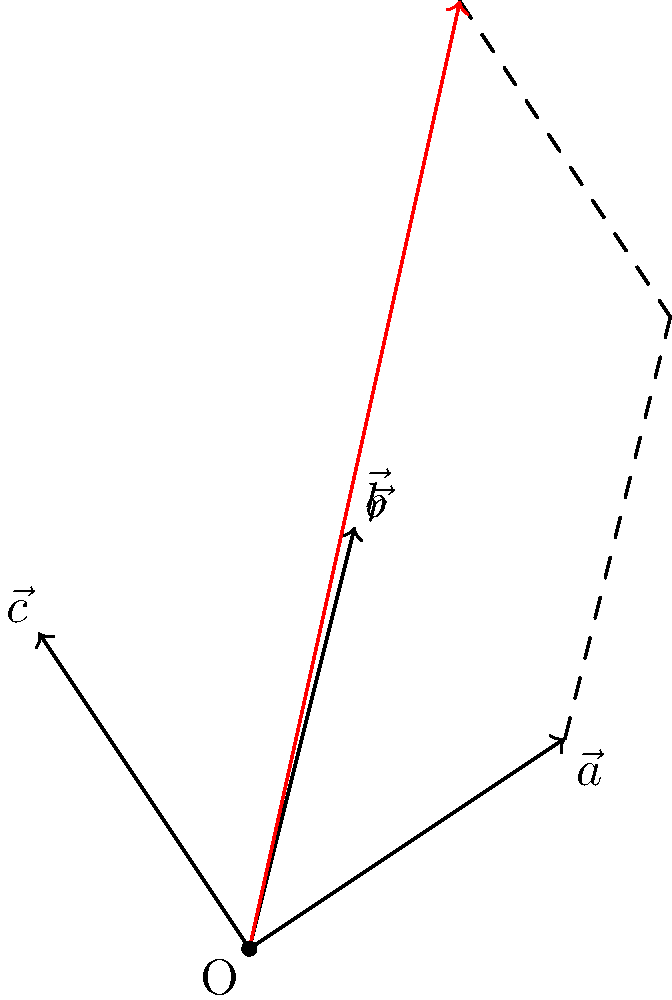As a lighting technician for your upcoming stage performance, you need to calculate the resultant vector of three spotlight beams. The spotlights are represented by vectors $\vec{a} = 3\hat{i} + 2\hat{j}$, $\vec{b} = \hat{i} + 4\hat{j}$, and $\vec{c} = -2\hat{i} + 3\hat{j}$. What is the magnitude of the resultant vector $\vec{r}$ to the nearest tenth? To find the magnitude of the resultant vector, we'll follow these steps:

1) First, we need to add the three vectors:
   $\vec{r} = \vec{a} + \vec{b} + \vec{c}$

2) Let's add the components:
   $\vec{r} = (3\hat{i} + 2\hat{j}) + (\hat{i} + 4\hat{j}) + (-2\hat{i} + 3\hat{j})$
   $\vec{r} = (3 + 1 - 2)\hat{i} + (2 + 4 + 3)\hat{j}$
   $\vec{r} = 2\hat{i} + 9\hat{j}$

3) Now that we have the resultant vector, we can calculate its magnitude using the Pythagorean theorem:
   $|\vec{r}| = \sqrt{x^2 + y^2}$, where $x = 2$ and $y = 9$

4) Plugging in the values:
   $|\vec{r}| = \sqrt{2^2 + 9^2}$
   $|\vec{r}| = \sqrt{4 + 81}$
   $|\vec{r}| = \sqrt{85}$

5) Using a calculator and rounding to the nearest tenth:
   $|\vec{r}| \approx 9.2$

Therefore, the magnitude of the resultant vector is approximately 9.2 units.
Answer: 9.2 